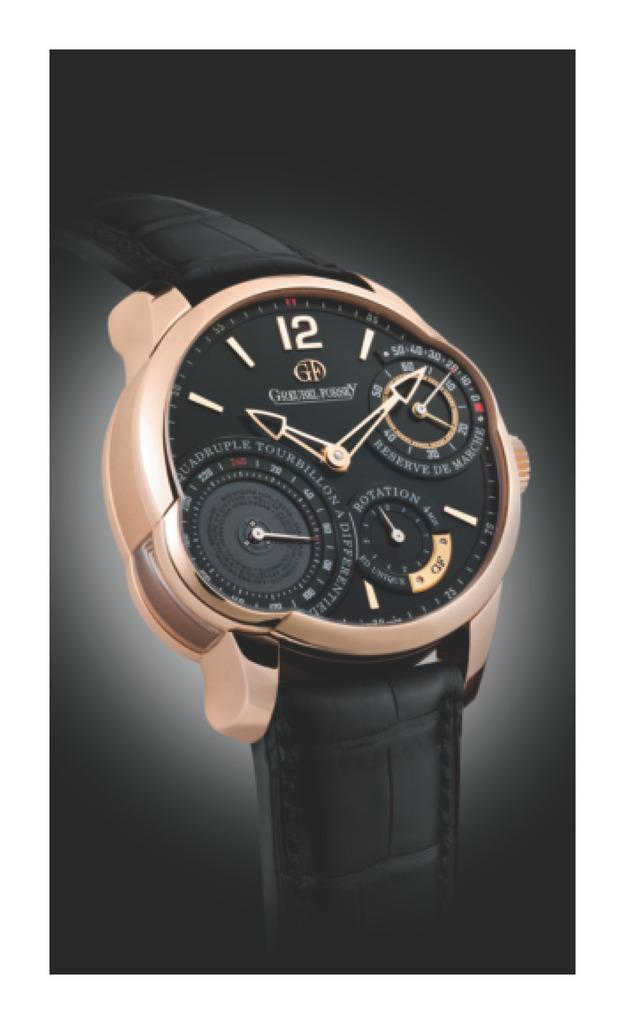<image>
Share a concise interpretation of the image provided. A watch with a light pink bezel and the letters "GF" on the top center of the face. 